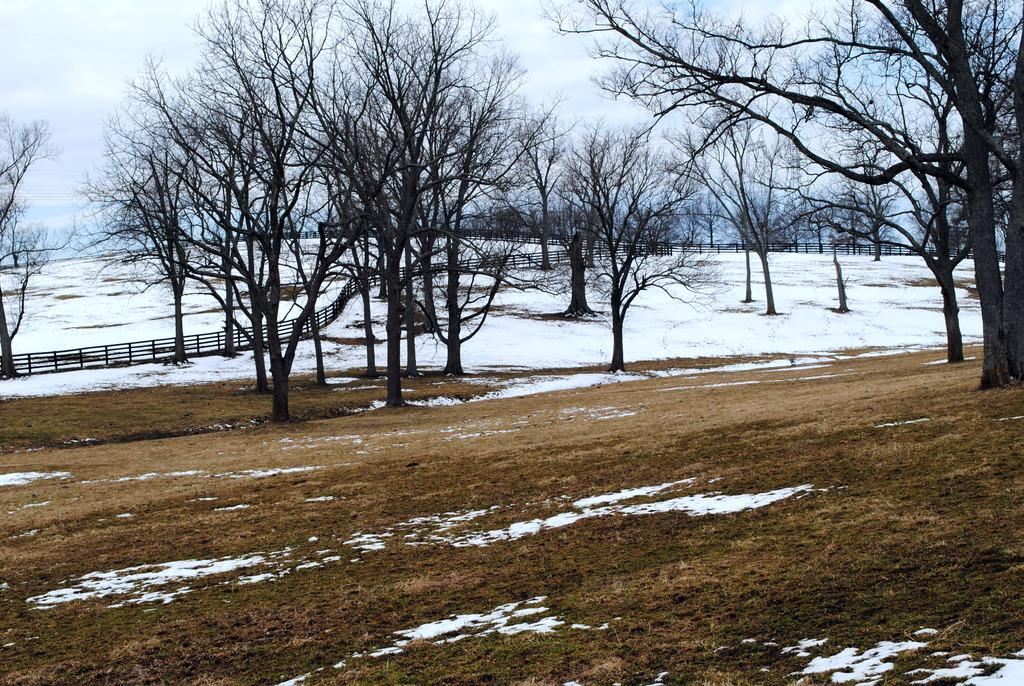What type of weather condition is depicted in the image? The image contains snow, indicating a winter scene. What type of structure can be seen in the image? There is a fence in the image. What type of natural elements are present in the image? Trees are present in the image. What is visible on the ground in the image? The ground is visible in the image. What is visible in the background of the image? The sky is visible in the background of the image. What is the level of disgust or attraction felt by the fence in the image? The image does not depict emotions or feelings of the fence, as it is an inanimate object. 